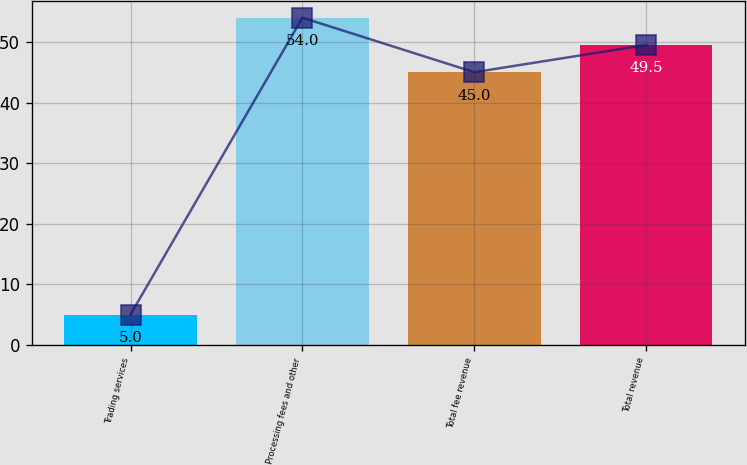<chart> <loc_0><loc_0><loc_500><loc_500><bar_chart><fcel>Trading services<fcel>Processing fees and other<fcel>Total fee revenue<fcel>Total revenue<nl><fcel>5<fcel>54<fcel>45<fcel>49.5<nl></chart> 